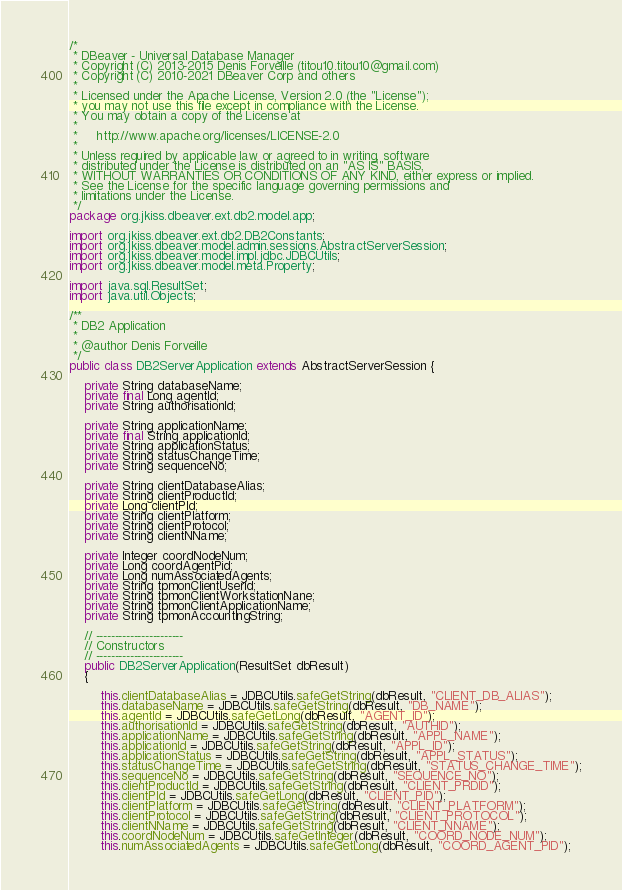<code> <loc_0><loc_0><loc_500><loc_500><_Java_>/*
 * DBeaver - Universal Database Manager
 * Copyright (C) 2013-2015 Denis Forveille (titou10.titou10@gmail.com)
 * Copyright (C) 2010-2021 DBeaver Corp and others
 *
 * Licensed under the Apache License, Version 2.0 (the "License");
 * you may not use this file except in compliance with the License.
 * You may obtain a copy of the License at
 *
 *     http://www.apache.org/licenses/LICENSE-2.0
 *
 * Unless required by applicable law or agreed to in writing, software
 * distributed under the License is distributed on an "AS IS" BASIS,
 * WITHOUT WARRANTIES OR CONDITIONS OF ANY KIND, either express or implied.
 * See the License for the specific language governing permissions and
 * limitations under the License.
 */
package org.jkiss.dbeaver.ext.db2.model.app;

import org.jkiss.dbeaver.ext.db2.DB2Constants;
import org.jkiss.dbeaver.model.admin.sessions.AbstractServerSession;
import org.jkiss.dbeaver.model.impl.jdbc.JDBCUtils;
import org.jkiss.dbeaver.model.meta.Property;

import java.sql.ResultSet;
import java.util.Objects;

/**
 * DB2 Application
 * 
 * @author Denis Forveille
 */
public class DB2ServerApplication extends AbstractServerSession {

    private String databaseName;
    private final Long agentId;
    private String authorisationId;

    private String applicationName;
    private final String applicationId;
    private String applicationStatus;
    private String statusChangeTime;
    private String sequenceNo;

    private String clientDatabaseAlias;
    private String clientProductId;
    private Long clientPId;
    private String clientPlatform;
    private String clientProtocol;
    private String clientNName;

    private Integer coordNodeNum;
    private Long coordAgentPid;
    private Long numAssociatedAgents;
    private String tpmonClientUserid;
    private String tpmonClientWorkstationNane;
    private String tpmonClientApplicationName;
    private String tpmonAccountingString;

    // -----------------------
    // Constructors
    // -----------------------
    public DB2ServerApplication(ResultSet dbResult)
    {

        this.clientDatabaseAlias = JDBCUtils.safeGetString(dbResult, "CLIENT_DB_ALIAS");
        this.databaseName = JDBCUtils.safeGetString(dbResult, "DB_NAME");
        this.agentId = JDBCUtils.safeGetLong(dbResult, "AGENT_ID");
        this.authorisationId = JDBCUtils.safeGetString(dbResult, "AUTHID");
        this.applicationName = JDBCUtils.safeGetString(dbResult, "APPL_NAME");
        this.applicationId = JDBCUtils.safeGetString(dbResult, "APPL_ID");
        this.applicationStatus = JDBCUtils.safeGetString(dbResult, "APPL_STATUS");
        this.statusChangeTime = JDBCUtils.safeGetString(dbResult, "STATUS_CHANGE_TIME");
        this.sequenceNo = JDBCUtils.safeGetString(dbResult, "SEQUENCE_NO");
        this.clientProductId = JDBCUtils.safeGetString(dbResult, "CLIENT_PRDID");
        this.clientPId = JDBCUtils.safeGetLong(dbResult, "CLIENT_PID");
        this.clientPlatform = JDBCUtils.safeGetString(dbResult, "CLIENT_PLATFORM");
        this.clientProtocol = JDBCUtils.safeGetString(dbResult, "CLIENT_PROTOCOL");
        this.clientNName = JDBCUtils.safeGetString(dbResult, "CLIENT_NNAME");
        this.coordNodeNum = JDBCUtils.safeGetInteger(dbResult, "COORD_NODE_NUM");
        this.numAssociatedAgents = JDBCUtils.safeGetLong(dbResult, "COORD_AGENT_PID");</code> 